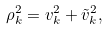<formula> <loc_0><loc_0><loc_500><loc_500>\rho _ { k } ^ { 2 } = v _ { k } ^ { 2 } + \tilde { v } _ { k } ^ { 2 } ,</formula> 